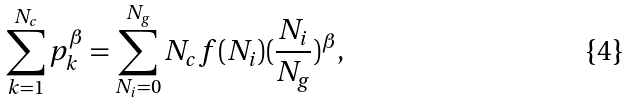Convert formula to latex. <formula><loc_0><loc_0><loc_500><loc_500>\sum _ { k = 1 } ^ { N _ { c } } p _ { k } ^ { \beta } = \sum _ { N _ { i } = 0 } ^ { N _ { g } } N _ { c } f ( N _ { i } ) ( \frac { N _ { i } } { N _ { g } } ) ^ { \beta } ,</formula> 